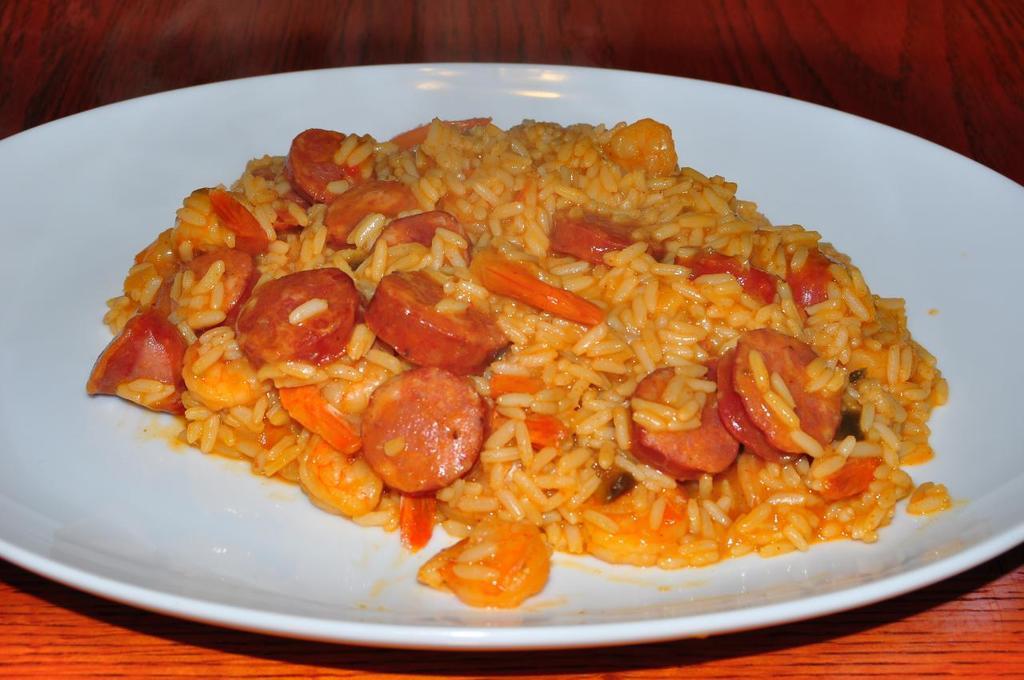In one or two sentences, can you explain what this image depicts? In this image we can see the food on the table. 